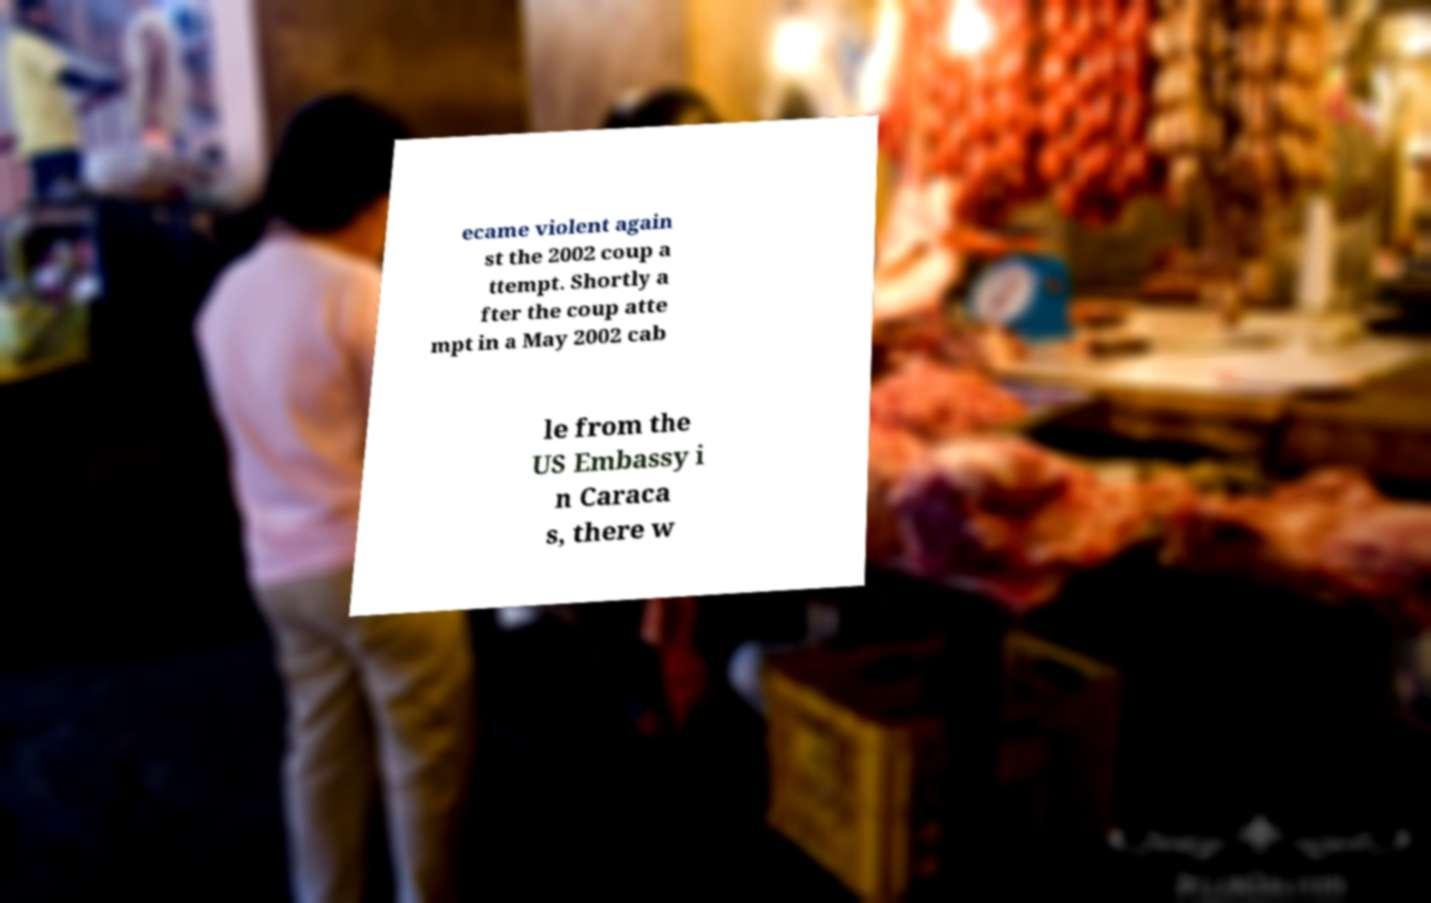There's text embedded in this image that I need extracted. Can you transcribe it verbatim? ecame violent again st the 2002 coup a ttempt. Shortly a fter the coup atte mpt in a May 2002 cab le from the US Embassy i n Caraca s, there w 